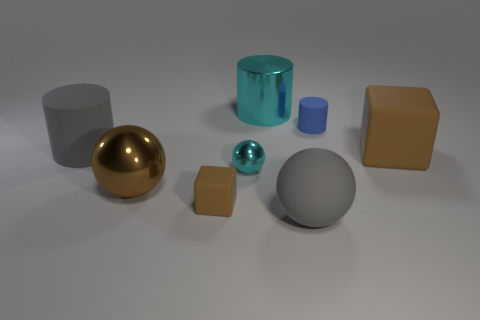Subtract all tiny blue cylinders. How many cylinders are left? 2 Subtract all blue cylinders. How many cylinders are left? 2 Add 2 gray shiny objects. How many objects exist? 10 Subtract 2 spheres. How many spheres are left? 1 Subtract all blue balls. Subtract all red cylinders. How many balls are left? 3 Subtract all gray cylinders. How many cyan balls are left? 1 Subtract all cyan shiny cylinders. Subtract all small cyan objects. How many objects are left? 6 Add 4 metallic objects. How many metallic objects are left? 7 Add 1 large rubber blocks. How many large rubber blocks exist? 2 Subtract 0 purple cubes. How many objects are left? 8 